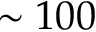Convert formula to latex. <formula><loc_0><loc_0><loc_500><loc_500>\sim 1 0 0</formula> 